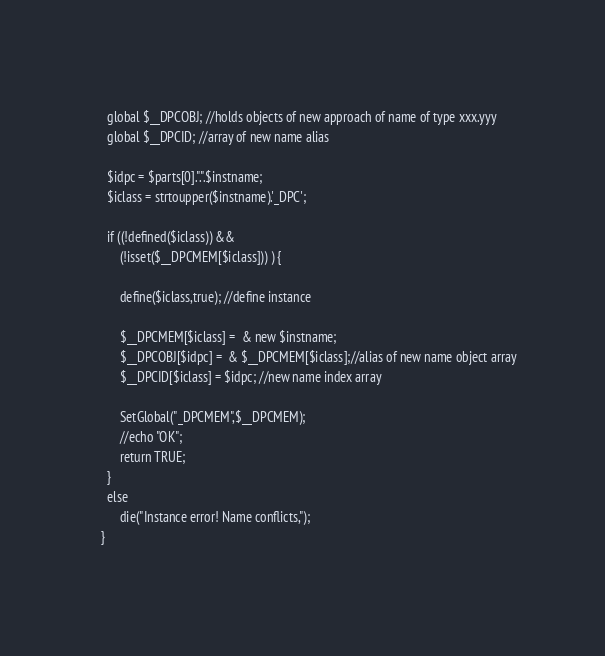<code> <loc_0><loc_0><loc_500><loc_500><_PHP_>	  
	  global $__DPCOBJ; //holds objects of new approach of name of type xxx.yyy
	  global $__DPCID; //array of new name alias		
	
	  $idpc = $parts[0].".".$instname;
	  $iclass = strtoupper($instname).'_DPC';	
	
	  if ((!defined($iclass)) &&
	      (!isset($__DPCMEM[$iclass])) ) {		
		  
		  define($iclass,true); //define instance
		
	      $__DPCMEM[$iclass] =  & new $instname;
		  $__DPCOBJ[$idpc] =  & $__DPCMEM[$iclass];//alias of new name object array
		  $__DPCID[$iclass] = $idpc; //new name index array		 
		
		  SetGlobal("_DPCMEM",$__DPCMEM);
		  //echo "OK";
		  return TRUE;
	  }
      else
		  die("Instance error! Name conflicts,"); 	 	
	}	
   	</code> 